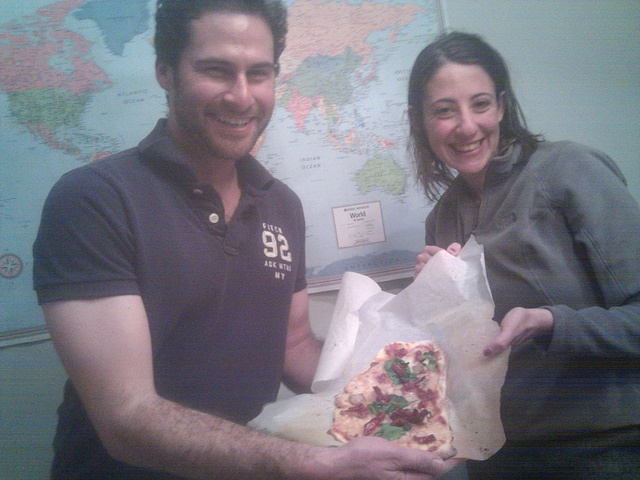Describe the objects in this image and their specific colors. I can see people in darkgray, gray, and purple tones, people in darkgray, gray, and black tones, and pizza in darkgray, lightpink, and gray tones in this image. 